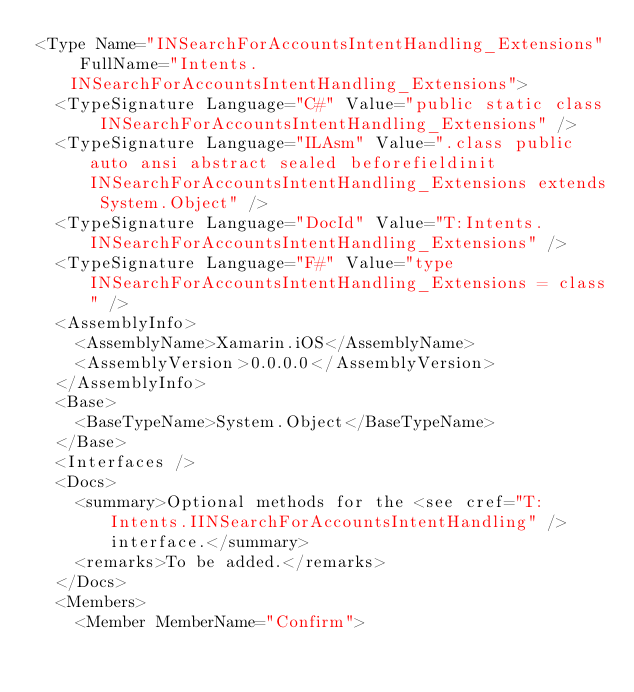Convert code to text. <code><loc_0><loc_0><loc_500><loc_500><_XML_><Type Name="INSearchForAccountsIntentHandling_Extensions" FullName="Intents.INSearchForAccountsIntentHandling_Extensions">
  <TypeSignature Language="C#" Value="public static class INSearchForAccountsIntentHandling_Extensions" />
  <TypeSignature Language="ILAsm" Value=".class public auto ansi abstract sealed beforefieldinit INSearchForAccountsIntentHandling_Extensions extends System.Object" />
  <TypeSignature Language="DocId" Value="T:Intents.INSearchForAccountsIntentHandling_Extensions" />
  <TypeSignature Language="F#" Value="type INSearchForAccountsIntentHandling_Extensions = class" />
  <AssemblyInfo>
    <AssemblyName>Xamarin.iOS</AssemblyName>
    <AssemblyVersion>0.0.0.0</AssemblyVersion>
  </AssemblyInfo>
  <Base>
    <BaseTypeName>System.Object</BaseTypeName>
  </Base>
  <Interfaces />
  <Docs>
    <summary>Optional methods for the <see cref="T:Intents.IINSearchForAccountsIntentHandling" /> interface.</summary>
    <remarks>To be added.</remarks>
  </Docs>
  <Members>
    <Member MemberName="Confirm"></code> 